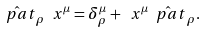<formula> <loc_0><loc_0><loc_500><loc_500>\hat { \ p a t } _ { \rho } \ x ^ { \mu } = \delta ^ { \mu } _ { \rho } + \ x ^ { \mu } \hat { \ p a t } _ { \rho } .</formula> 